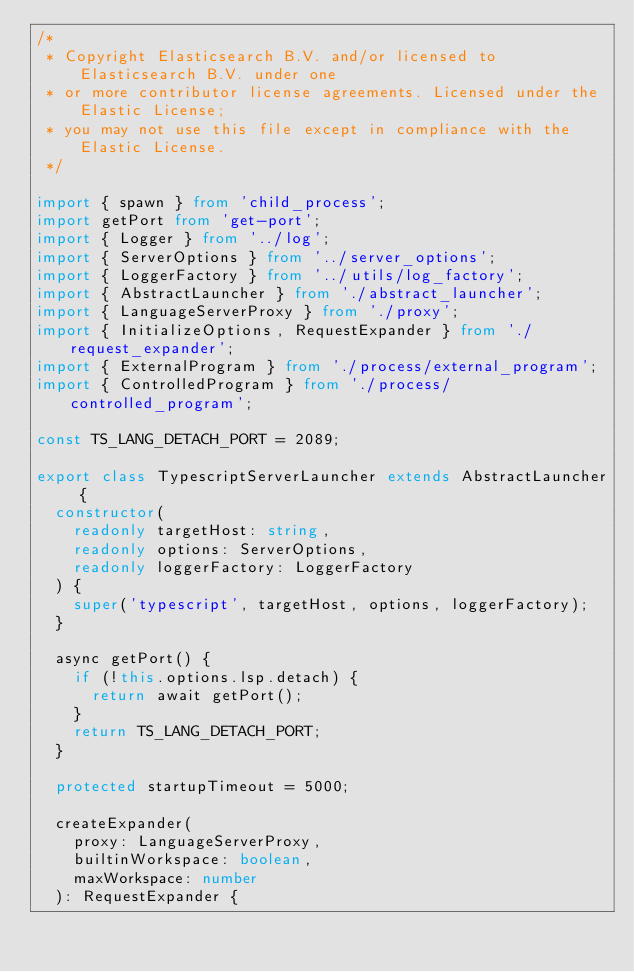<code> <loc_0><loc_0><loc_500><loc_500><_TypeScript_>/*
 * Copyright Elasticsearch B.V. and/or licensed to Elasticsearch B.V. under one
 * or more contributor license agreements. Licensed under the Elastic License;
 * you may not use this file except in compliance with the Elastic License.
 */

import { spawn } from 'child_process';
import getPort from 'get-port';
import { Logger } from '../log';
import { ServerOptions } from '../server_options';
import { LoggerFactory } from '../utils/log_factory';
import { AbstractLauncher } from './abstract_launcher';
import { LanguageServerProxy } from './proxy';
import { InitializeOptions, RequestExpander } from './request_expander';
import { ExternalProgram } from './process/external_program';
import { ControlledProgram } from './process/controlled_program';

const TS_LANG_DETACH_PORT = 2089;

export class TypescriptServerLauncher extends AbstractLauncher {
  constructor(
    readonly targetHost: string,
    readonly options: ServerOptions,
    readonly loggerFactory: LoggerFactory
  ) {
    super('typescript', targetHost, options, loggerFactory);
  }

  async getPort() {
    if (!this.options.lsp.detach) {
      return await getPort();
    }
    return TS_LANG_DETACH_PORT;
  }

  protected startupTimeout = 5000;

  createExpander(
    proxy: LanguageServerProxy,
    builtinWorkspace: boolean,
    maxWorkspace: number
  ): RequestExpander {</code> 